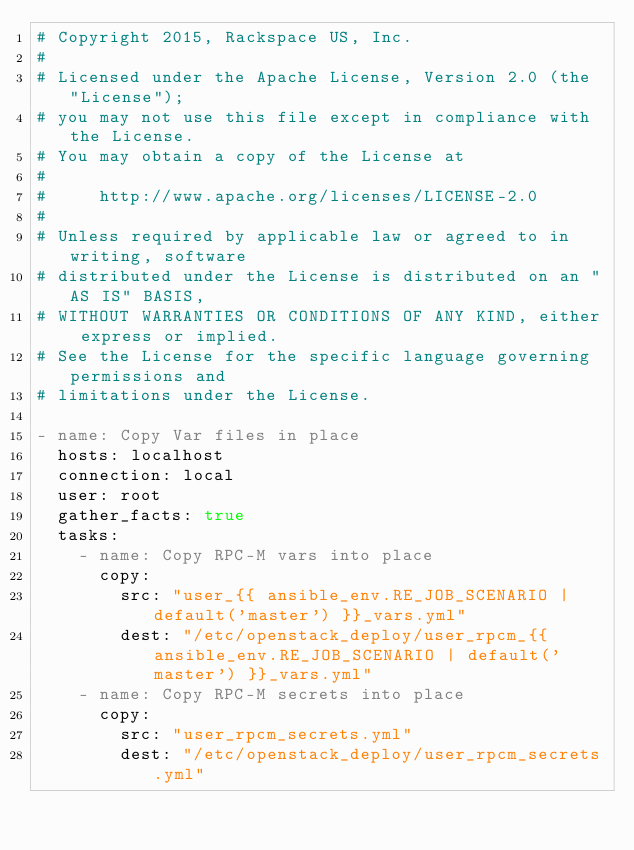<code> <loc_0><loc_0><loc_500><loc_500><_YAML_># Copyright 2015, Rackspace US, Inc.
#
# Licensed under the Apache License, Version 2.0 (the "License");
# you may not use this file except in compliance with the License.
# You may obtain a copy of the License at
#
#     http://www.apache.org/licenses/LICENSE-2.0
#
# Unless required by applicable law or agreed to in writing, software
# distributed under the License is distributed on an "AS IS" BASIS,
# WITHOUT WARRANTIES OR CONDITIONS OF ANY KIND, either express or implied.
# See the License for the specific language governing permissions and
# limitations under the License.

- name: Copy Var files in place
  hosts: localhost
  connection: local
  user: root
  gather_facts: true
  tasks:
    - name: Copy RPC-M vars into place
      copy:
        src: "user_{{ ansible_env.RE_JOB_SCENARIO | default('master') }}_vars.yml"
        dest: "/etc/openstack_deploy/user_rpcm_{{ ansible_env.RE_JOB_SCENARIO | default('master') }}_vars.yml"
    - name: Copy RPC-M secrets into place
      copy:
        src: "user_rpcm_secrets.yml"
        dest: "/etc/openstack_deploy/user_rpcm_secrets.yml"
</code> 